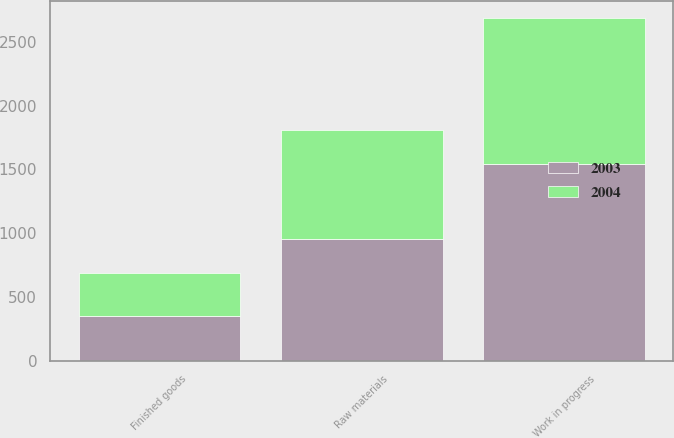Convert chart. <chart><loc_0><loc_0><loc_500><loc_500><stacked_bar_chart><ecel><fcel>Raw materials<fcel>Work in progress<fcel>Finished goods<nl><fcel>2003<fcel>953<fcel>1547<fcel>352<nl><fcel>2004<fcel>859<fcel>1140<fcel>335<nl></chart> 